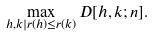<formula> <loc_0><loc_0><loc_500><loc_500>\max _ { h , k | r ( h ) \leq r ( k ) } D [ h , k ; n ] .</formula> 